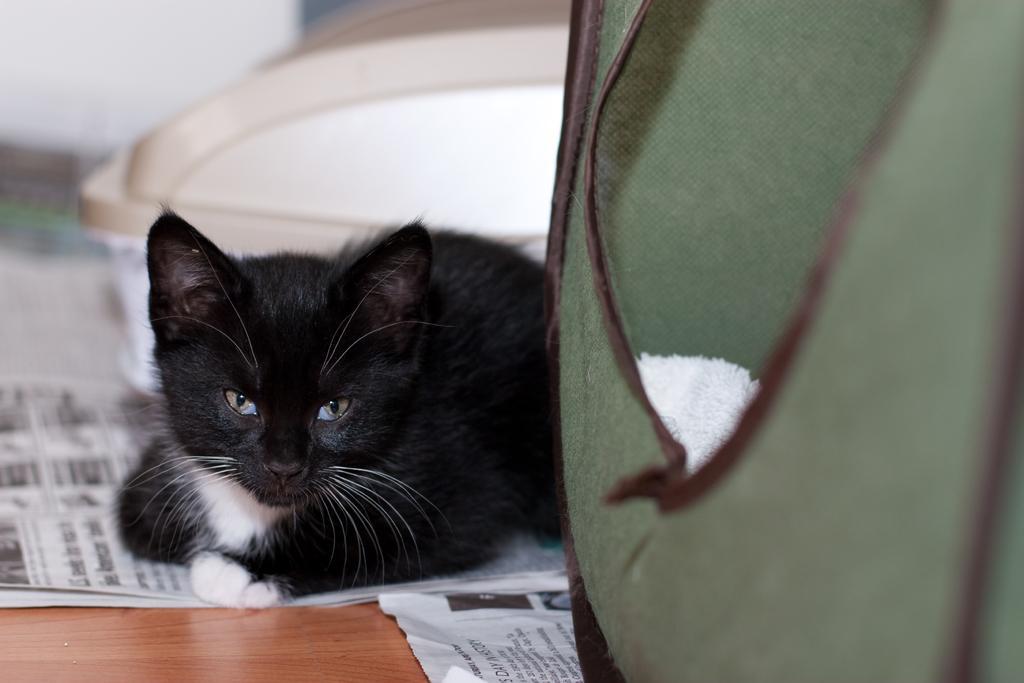How would you summarize this image in a sentence or two? In this image we can see a cat lying on a paper. On the paper, we have some text. On the right side, we can see a bag. In the bottom left we can see a wooden surface. Behind the cat, we can see an object. The background of the image is blurred. 